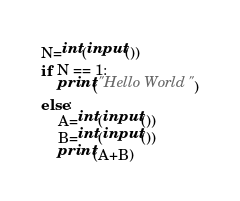<code> <loc_0><loc_0><loc_500><loc_500><_Python_>N=int(input())
if N == 1:
    print("Hello World")
else:
    A=int(input())
    B=int(input())
    print(A+B)</code> 